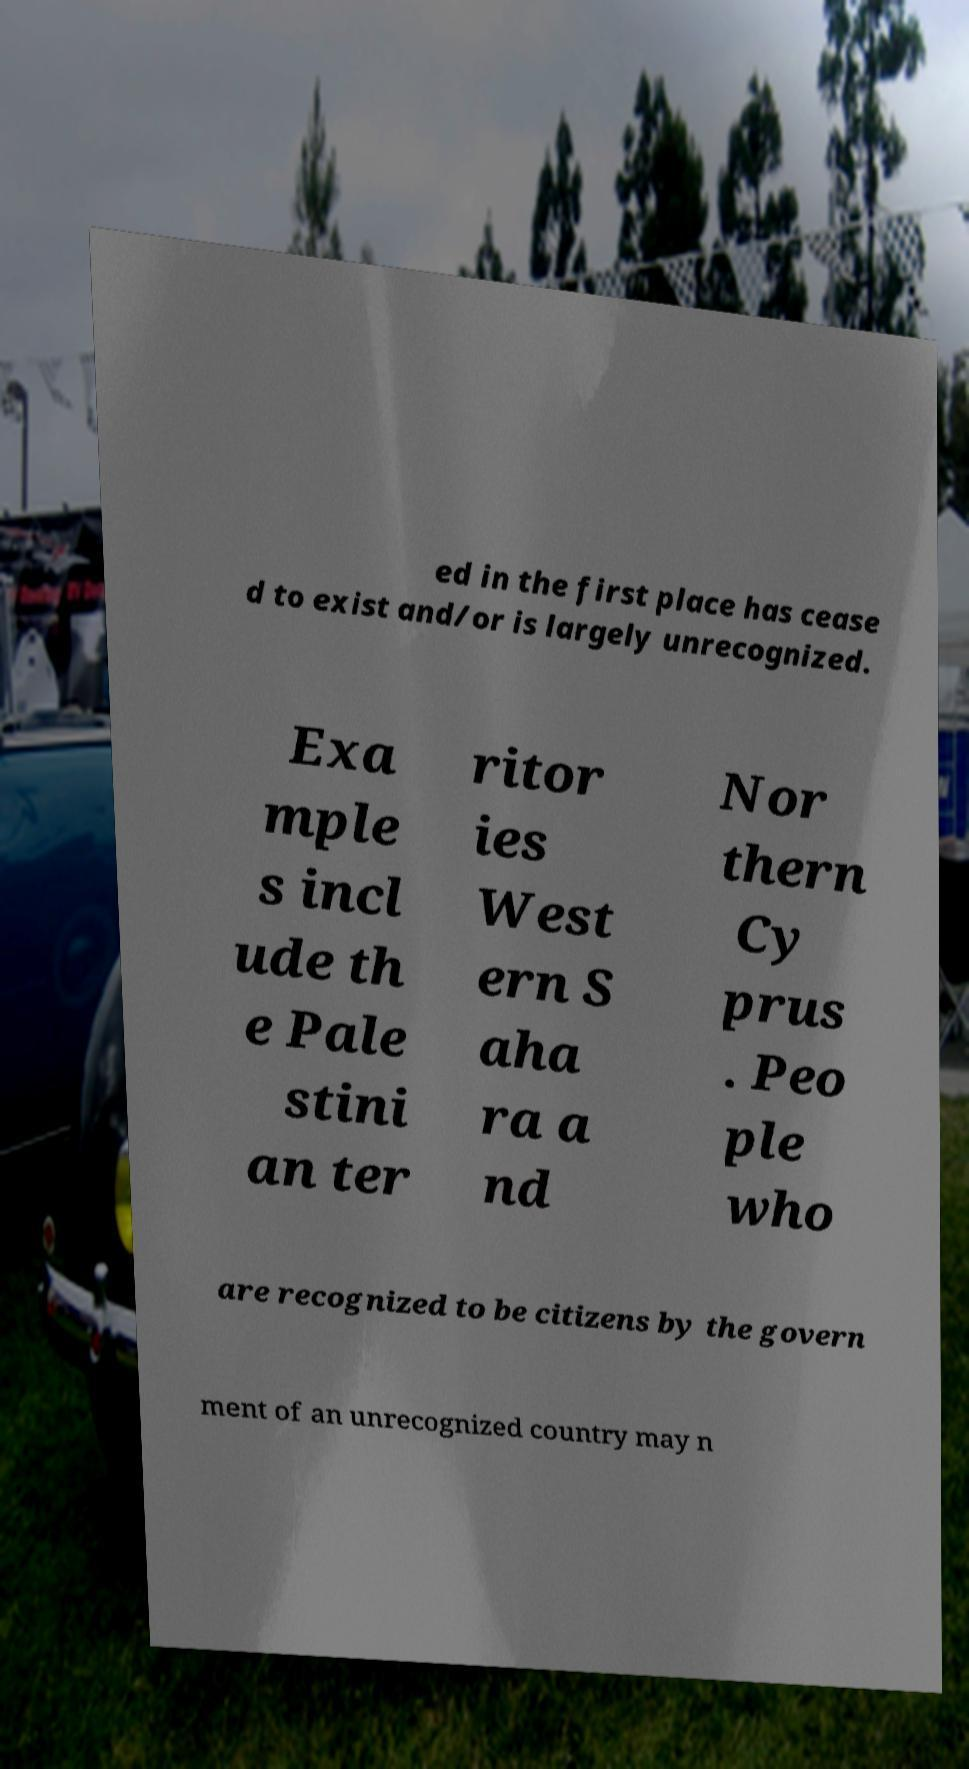Please read and relay the text visible in this image. What does it say? ed in the first place has cease d to exist and/or is largely unrecognized. Exa mple s incl ude th e Pale stini an ter ritor ies West ern S aha ra a nd Nor thern Cy prus . Peo ple who are recognized to be citizens by the govern ment of an unrecognized country may n 